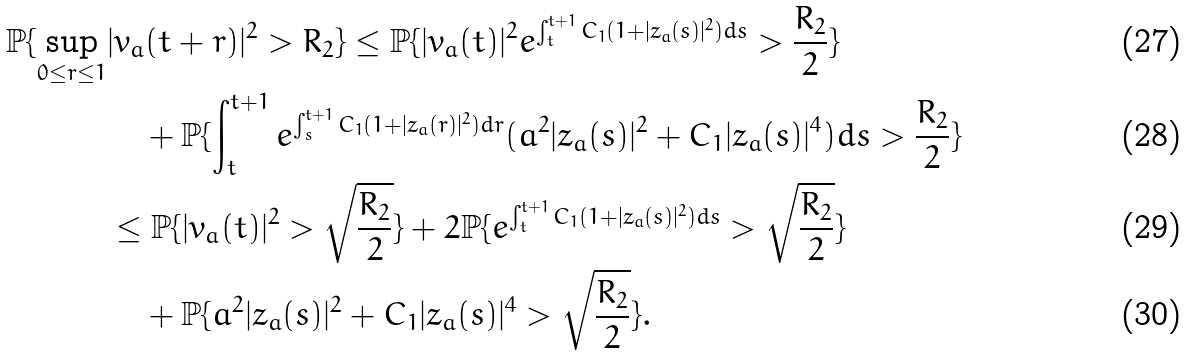<formula> <loc_0><loc_0><loc_500><loc_500>\mathbb { P } \{ \sup _ { 0 \leq r \leq 1 } & | v _ { a } ( t + r ) | ^ { 2 } > R _ { 2 } \} \leq \mathbb { P } \{ | v _ { a } ( t ) | ^ { 2 } e ^ { \int _ { t } ^ { t + 1 } C _ { 1 } ( 1 + | z _ { a } ( s ) | ^ { 2 } ) d s } > \frac { R _ { 2 } } 2 \} \\ & \quad + \mathbb { P } \{ \int _ { t } ^ { t + 1 } e ^ { \int _ { s } ^ { t + 1 } C _ { 1 } ( 1 + | z _ { a } ( r ) | ^ { 2 } ) d r } ( a ^ { 2 } | z _ { a } ( s ) | ^ { 2 } + C _ { 1 } | z _ { a } ( s ) | ^ { 4 } ) d s > \frac { R _ { 2 } } 2 \} \\ & \leq \mathbb { P } \{ | v _ { a } ( t ) | ^ { 2 } > \sqrt { \frac { R _ { 2 } } 2 } \} + 2 \mathbb { P } \{ e ^ { \int _ { t } ^ { t + 1 } C _ { 1 } ( 1 + | z _ { a } ( s ) | ^ { 2 } ) d s } > \sqrt { \frac { R _ { 2 } } 2 } \} \\ & \quad + \mathbb { P } \{ a ^ { 2 } | z _ { a } ( s ) | ^ { 2 } + C _ { 1 } | z _ { a } ( s ) | ^ { 4 } > \sqrt { \frac { R _ { 2 } } 2 } \} .</formula> 